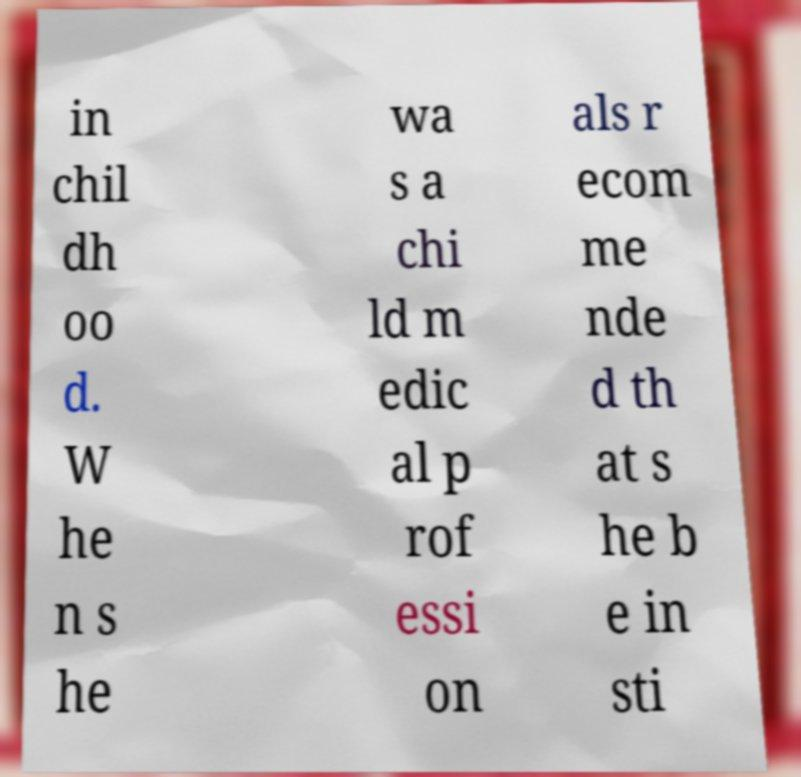I need the written content from this picture converted into text. Can you do that? in chil dh oo d. W he n s he wa s a chi ld m edic al p rof essi on als r ecom me nde d th at s he b e in sti 